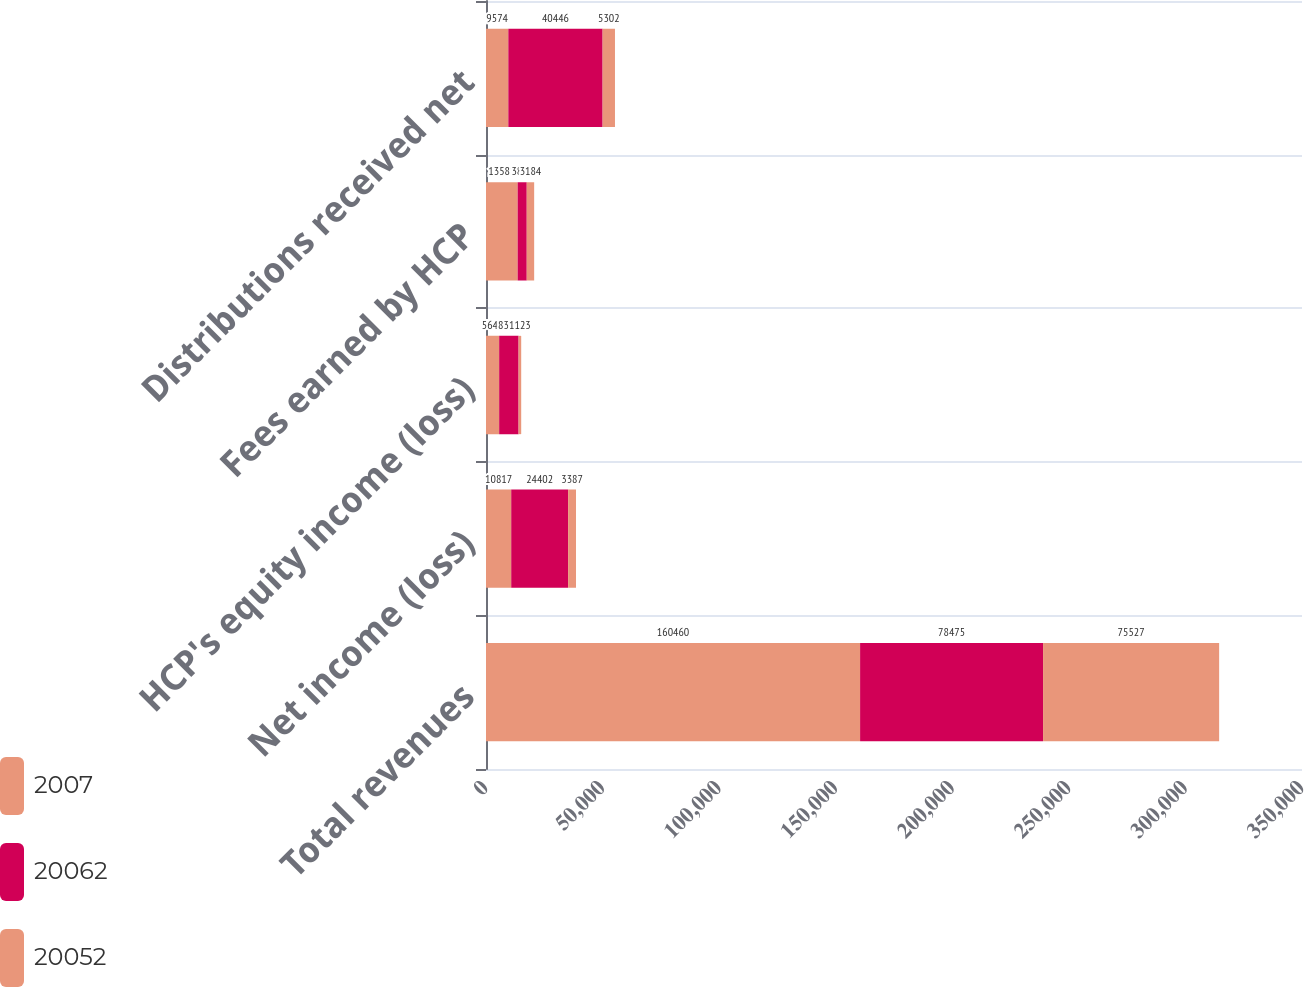Convert chart to OTSL. <chart><loc_0><loc_0><loc_500><loc_500><stacked_bar_chart><ecel><fcel>Total revenues<fcel>Net income (loss)<fcel>HCP's equity income (loss)<fcel>Fees earned by HCP<fcel>Distributions received net<nl><fcel>2007<fcel>160460<fcel>10817<fcel>5645<fcel>13581<fcel>9574<nl><fcel>20062<fcel>78475<fcel>24402<fcel>8331<fcel>3895<fcel>40446<nl><fcel>20052<fcel>75527<fcel>3387<fcel>1123<fcel>3184<fcel>5302<nl></chart> 